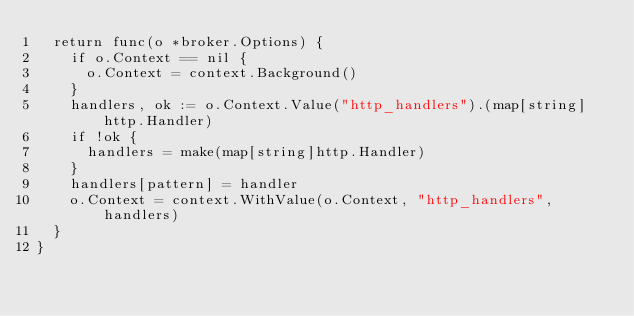Convert code to text. <code><loc_0><loc_0><loc_500><loc_500><_Go_>	return func(o *broker.Options) {
		if o.Context == nil {
			o.Context = context.Background()
		}
		handlers, ok := o.Context.Value("http_handlers").(map[string]http.Handler)
		if !ok {
			handlers = make(map[string]http.Handler)
		}
		handlers[pattern] = handler
		o.Context = context.WithValue(o.Context, "http_handlers", handlers)
	}
}
</code> 